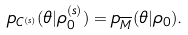Convert formula to latex. <formula><loc_0><loc_0><loc_500><loc_500>p _ { C ^ { ( s ) } } ( \theta | \rho _ { 0 } ^ { ( s ) } ) = p _ { \overline { M } } ( \theta | \rho _ { 0 } ) .</formula> 